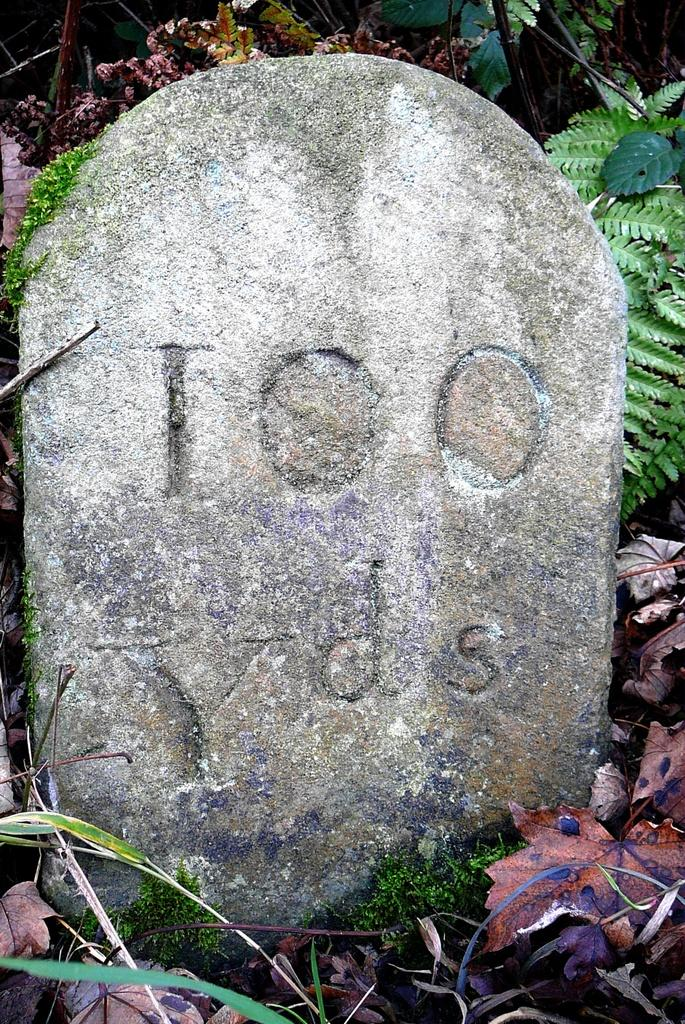What type of location is shown in the image? The image depicts a cemetery. What can be seen in the background of the image? There are plants and leaves visible in the background. What type of transport is being used by the rod in the image? There is no rod present in the image, and therefore no transport can be associated with it. 